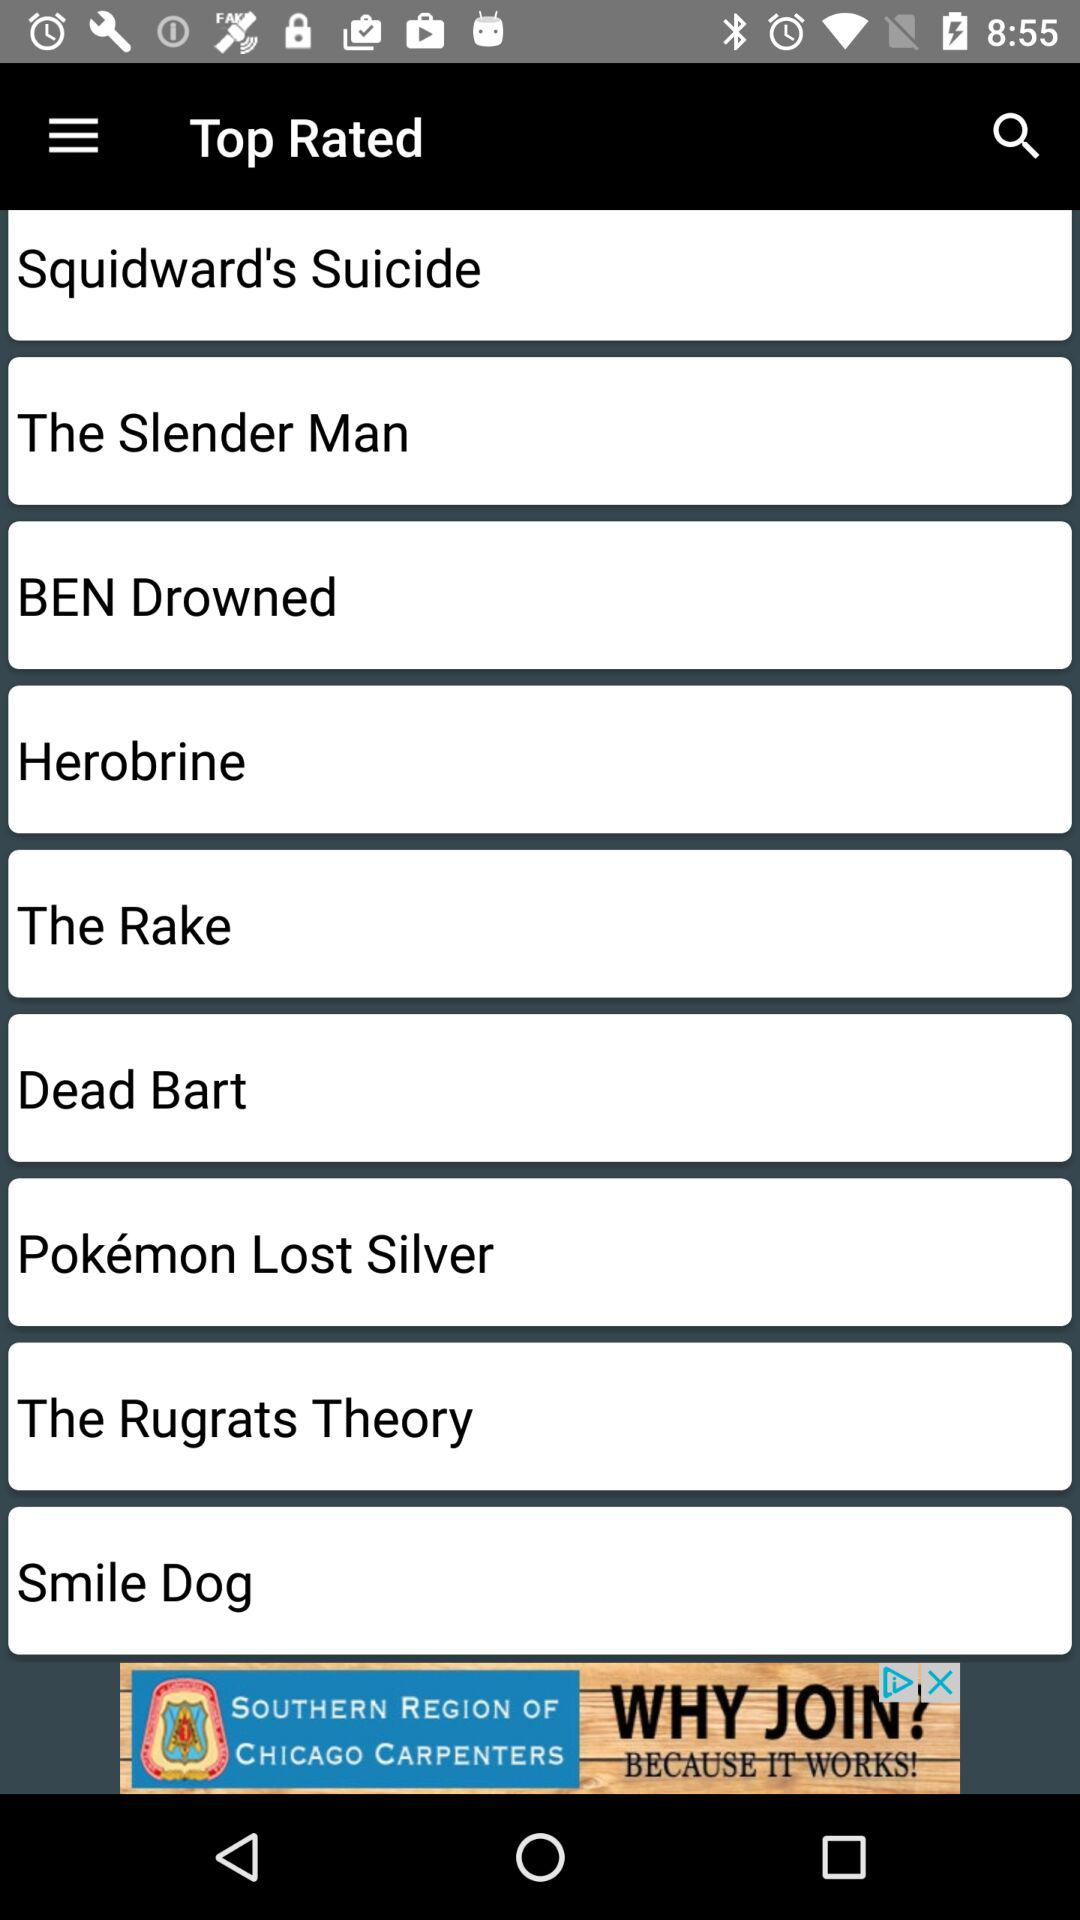What is the list of top rated content? The list of top rated content is "Squidward's Suicide", "The Slender Man", "BEN Drowned", "Herobrine", "The Rake", "Dead Bart", "Pokémon Lost Silver", "The Rugrats Theory" and "Smile Dog". 